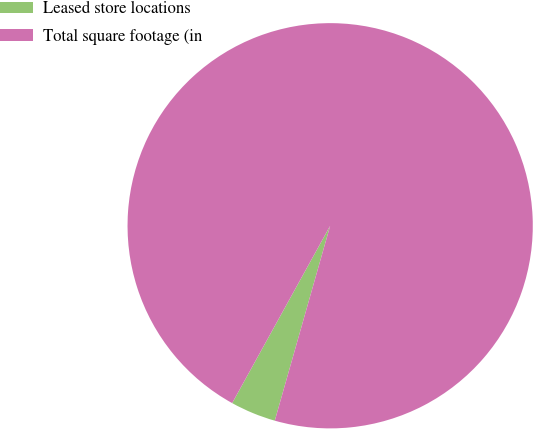Convert chart to OTSL. <chart><loc_0><loc_0><loc_500><loc_500><pie_chart><fcel>Leased store locations<fcel>Total square footage (in<nl><fcel>3.63%<fcel>96.37%<nl></chart> 